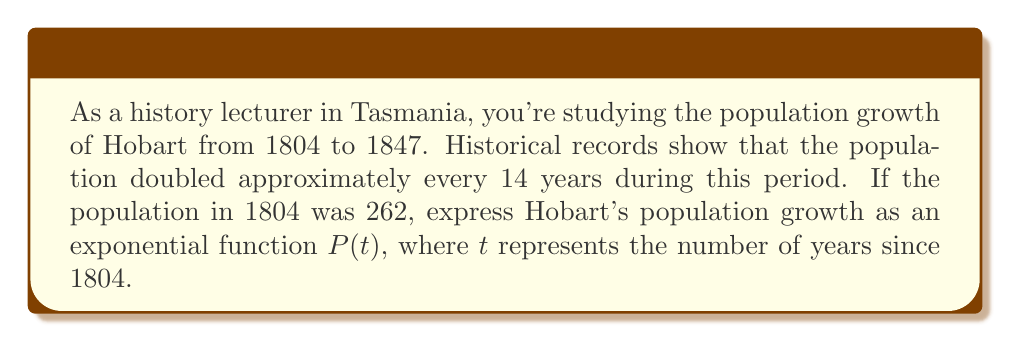Help me with this question. 1. The general form of an exponential growth function is:
   $P(t) = P_0 \cdot b^t$
   where $P_0$ is the initial population, $b$ is the growth factor, and $t$ is time.

2. We know that $P_0 = 262$ (the population in 1804).

3. To find $b$, we use the doubling time:
   $2 = b^{14}$ (population doubles every 14 years)

4. Solve for $b$:
   $b = 2^{\frac{1}{14}} \approx 1.0507$

5. Now we can write our exponential function:
   $P(t) = 262 \cdot (1.0507)^t$

6. To simplify, we can use the properties of exponents:
   $P(t) = 262 \cdot (2^{\frac{1}{14}})^t = 262 \cdot 2^{\frac{t}{14}}$

Therefore, the exponential function representing Hobart's population growth from 1804 to 1847 is:
$P(t) = 262 \cdot 2^{\frac{t}{14}}$
Answer: $P(t) = 262 \cdot 2^{\frac{t}{14}}$ 